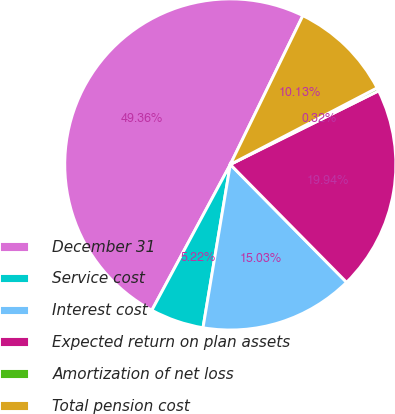Convert chart to OTSL. <chart><loc_0><loc_0><loc_500><loc_500><pie_chart><fcel>December 31<fcel>Service cost<fcel>Interest cost<fcel>Expected return on plan assets<fcel>Amortization of net loss<fcel>Total pension cost<nl><fcel>49.36%<fcel>5.22%<fcel>15.03%<fcel>19.94%<fcel>0.32%<fcel>10.13%<nl></chart> 